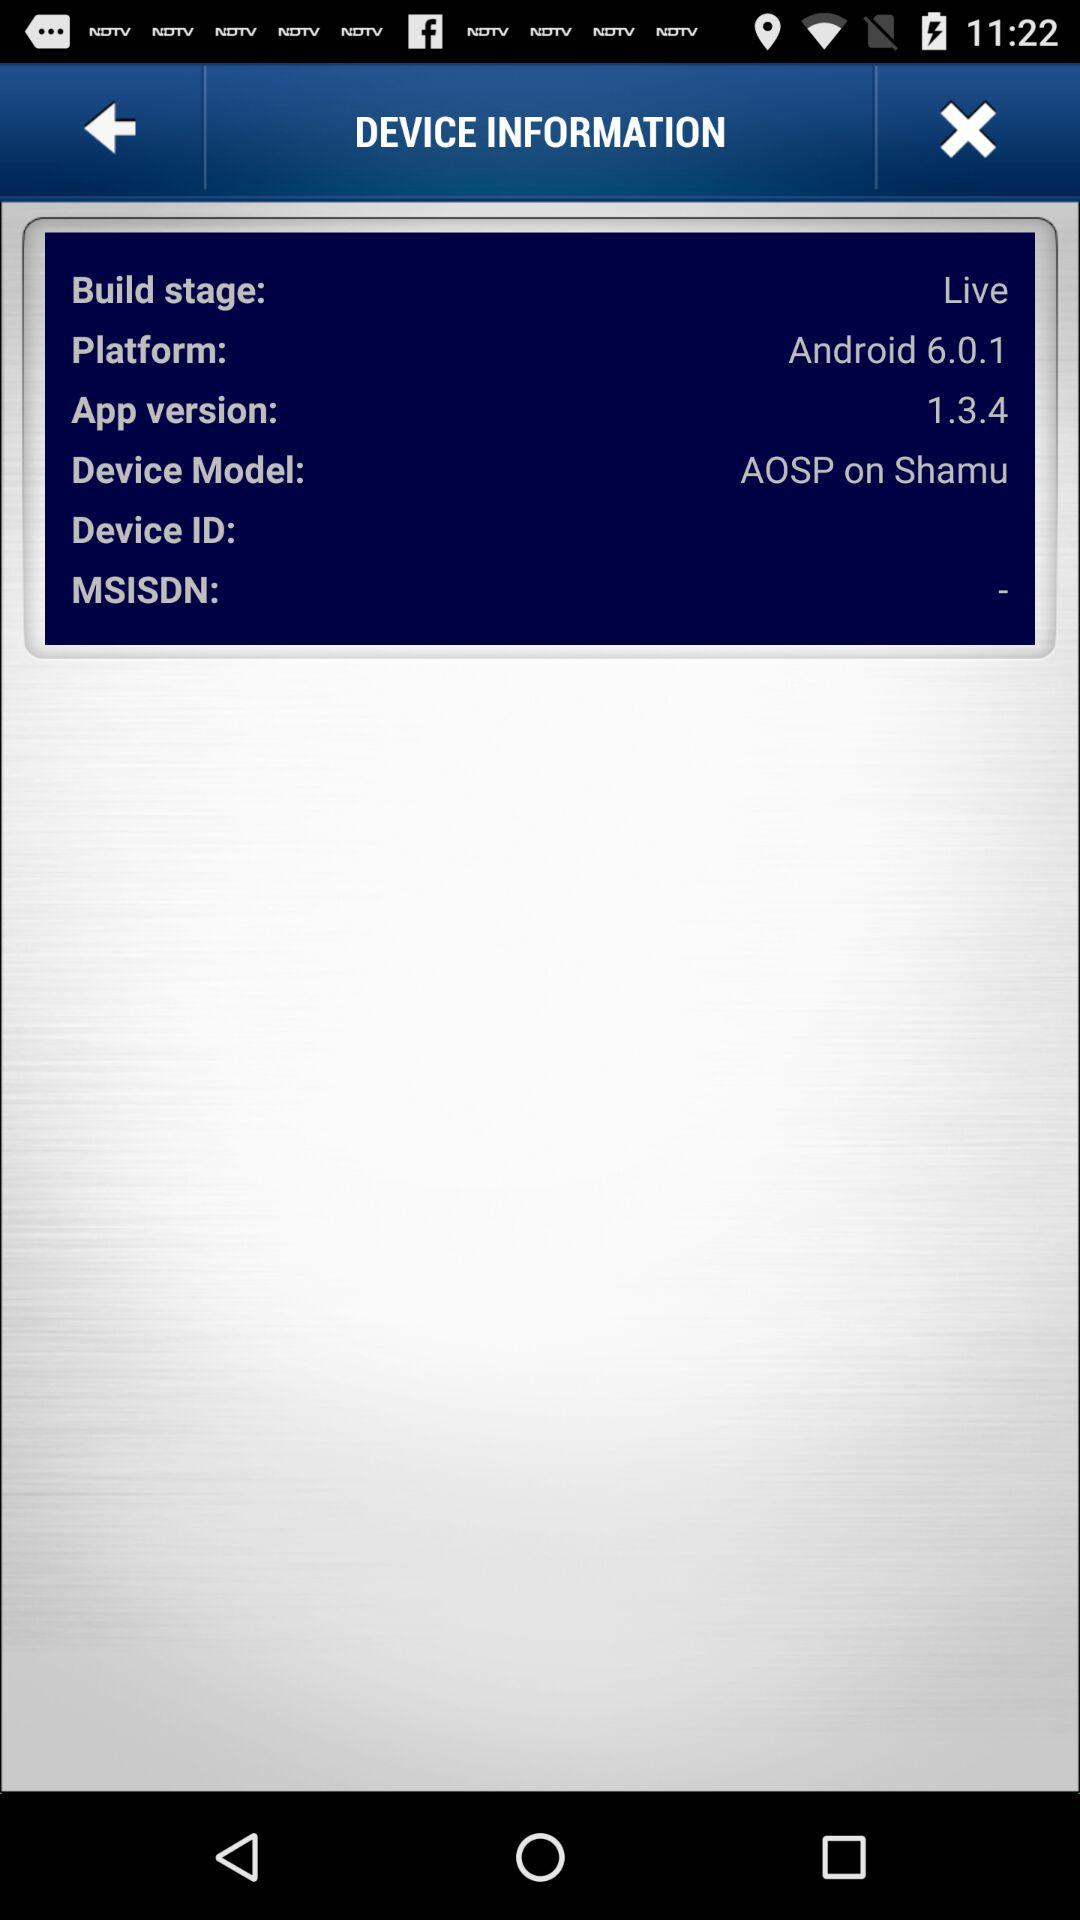What platform is used? The used platform is Android 6.0.1. 